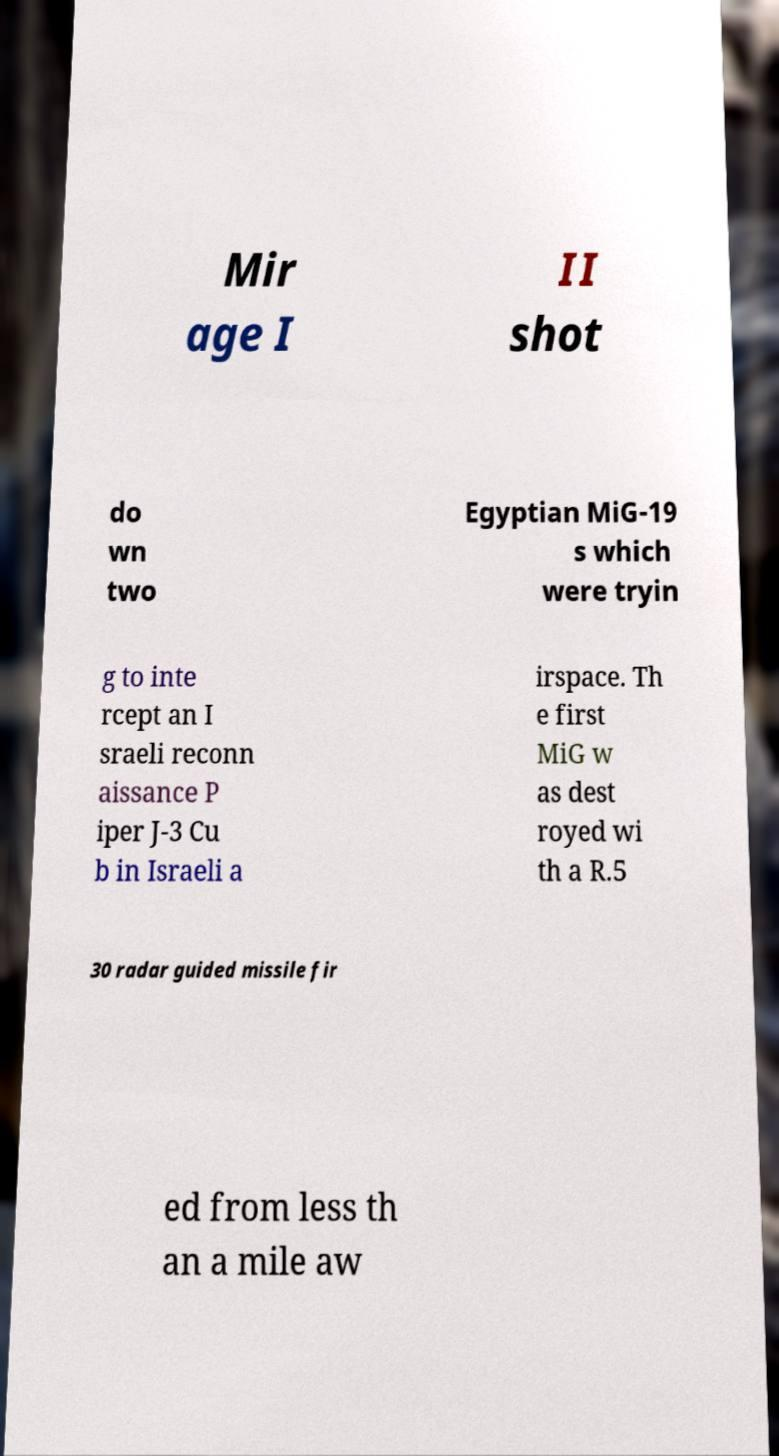Could you extract and type out the text from this image? Mir age I II shot do wn two Egyptian MiG-19 s which were tryin g to inte rcept an I sraeli reconn aissance P iper J-3 Cu b in Israeli a irspace. Th e first MiG w as dest royed wi th a R.5 30 radar guided missile fir ed from less th an a mile aw 